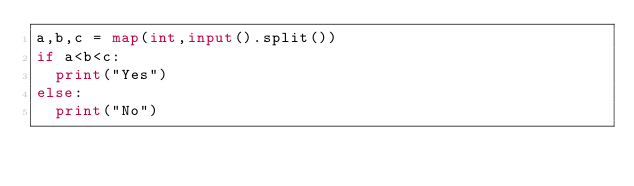<code> <loc_0><loc_0><loc_500><loc_500><_Python_>a,b,c = map(int,input().split())
if a<b<c:
  print("Yes")
else:
  print("No")
</code> 